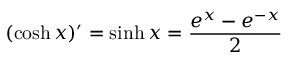<formula> <loc_0><loc_0><loc_500><loc_500>( \cosh x ) ^ { \prime } = \sinh x = { \frac { e ^ { x } - e ^ { - x } } { 2 } }</formula> 